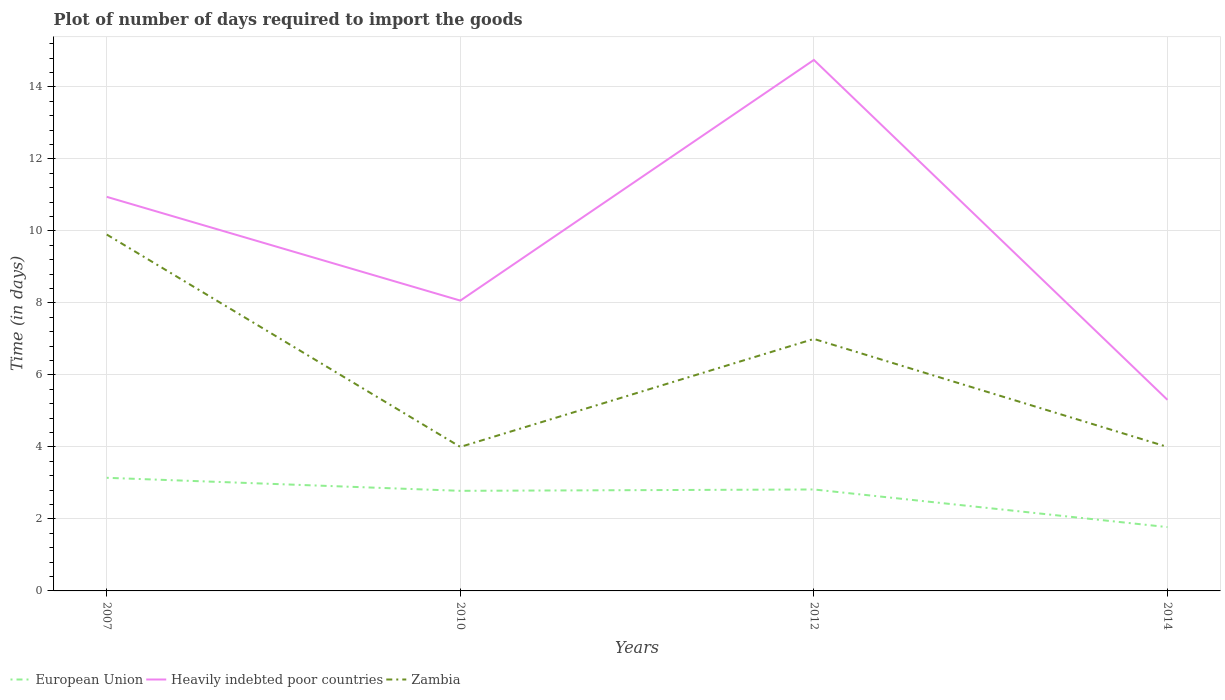Does the line corresponding to Zambia intersect with the line corresponding to European Union?
Make the answer very short. No. Is the number of lines equal to the number of legend labels?
Your response must be concise. Yes. Across all years, what is the maximum time required to import goods in European Union?
Your answer should be very brief. 1.77. In which year was the time required to import goods in Heavily indebted poor countries maximum?
Your answer should be very brief. 2014. What is the total time required to import goods in European Union in the graph?
Provide a succinct answer. 1.37. What is the difference between the highest and the second highest time required to import goods in Zambia?
Provide a short and direct response. 5.9. Is the time required to import goods in Zambia strictly greater than the time required to import goods in Heavily indebted poor countries over the years?
Ensure brevity in your answer.  Yes. How many lines are there?
Your answer should be compact. 3. Are the values on the major ticks of Y-axis written in scientific E-notation?
Ensure brevity in your answer.  No. Where does the legend appear in the graph?
Make the answer very short. Bottom left. How many legend labels are there?
Offer a very short reply. 3. What is the title of the graph?
Provide a succinct answer. Plot of number of days required to import the goods. Does "Moldova" appear as one of the legend labels in the graph?
Make the answer very short. No. What is the label or title of the X-axis?
Provide a short and direct response. Years. What is the label or title of the Y-axis?
Your answer should be compact. Time (in days). What is the Time (in days) of European Union in 2007?
Offer a very short reply. 3.14. What is the Time (in days) of Heavily indebted poor countries in 2007?
Your answer should be compact. 10.95. What is the Time (in days) in European Union in 2010?
Your response must be concise. 2.78. What is the Time (in days) of Heavily indebted poor countries in 2010?
Make the answer very short. 8.06. What is the Time (in days) of Zambia in 2010?
Your response must be concise. 4. What is the Time (in days) of European Union in 2012?
Keep it short and to the point. 2.82. What is the Time (in days) in Heavily indebted poor countries in 2012?
Offer a terse response. 14.75. What is the Time (in days) in Zambia in 2012?
Your answer should be compact. 7. What is the Time (in days) of European Union in 2014?
Offer a terse response. 1.77. What is the Time (in days) of Heavily indebted poor countries in 2014?
Your answer should be very brief. 5.31. What is the Time (in days) of Zambia in 2014?
Offer a very short reply. 4. Across all years, what is the maximum Time (in days) in European Union?
Keep it short and to the point. 3.14. Across all years, what is the maximum Time (in days) in Heavily indebted poor countries?
Keep it short and to the point. 14.75. Across all years, what is the maximum Time (in days) in Zambia?
Provide a succinct answer. 9.9. Across all years, what is the minimum Time (in days) in European Union?
Provide a short and direct response. 1.77. Across all years, what is the minimum Time (in days) of Heavily indebted poor countries?
Offer a terse response. 5.31. Across all years, what is the minimum Time (in days) in Zambia?
Make the answer very short. 4. What is the total Time (in days) in European Union in the graph?
Offer a very short reply. 10.51. What is the total Time (in days) in Heavily indebted poor countries in the graph?
Provide a succinct answer. 39.07. What is the total Time (in days) in Zambia in the graph?
Give a very brief answer. 24.9. What is the difference between the Time (in days) of European Union in 2007 and that in 2010?
Your response must be concise. 0.36. What is the difference between the Time (in days) of Heavily indebted poor countries in 2007 and that in 2010?
Your response must be concise. 2.88. What is the difference between the Time (in days) of Zambia in 2007 and that in 2010?
Keep it short and to the point. 5.9. What is the difference between the Time (in days) in European Union in 2007 and that in 2012?
Ensure brevity in your answer.  0.32. What is the difference between the Time (in days) in Heavily indebted poor countries in 2007 and that in 2012?
Your response must be concise. -3.8. What is the difference between the Time (in days) of European Union in 2007 and that in 2014?
Make the answer very short. 1.37. What is the difference between the Time (in days) of Heavily indebted poor countries in 2007 and that in 2014?
Provide a succinct answer. 5.64. What is the difference between the Time (in days) in European Union in 2010 and that in 2012?
Make the answer very short. -0.04. What is the difference between the Time (in days) of Heavily indebted poor countries in 2010 and that in 2012?
Your answer should be compact. -6.69. What is the difference between the Time (in days) in European Union in 2010 and that in 2014?
Your answer should be very brief. 1.01. What is the difference between the Time (in days) in Heavily indebted poor countries in 2010 and that in 2014?
Ensure brevity in your answer.  2.76. What is the difference between the Time (in days) in Zambia in 2010 and that in 2014?
Ensure brevity in your answer.  0. What is the difference between the Time (in days) of European Union in 2012 and that in 2014?
Make the answer very short. 1.05. What is the difference between the Time (in days) of Heavily indebted poor countries in 2012 and that in 2014?
Ensure brevity in your answer.  9.44. What is the difference between the Time (in days) of Zambia in 2012 and that in 2014?
Provide a short and direct response. 3. What is the difference between the Time (in days) of European Union in 2007 and the Time (in days) of Heavily indebted poor countries in 2010?
Your answer should be compact. -4.92. What is the difference between the Time (in days) in European Union in 2007 and the Time (in days) in Zambia in 2010?
Provide a succinct answer. -0.86. What is the difference between the Time (in days) in Heavily indebted poor countries in 2007 and the Time (in days) in Zambia in 2010?
Offer a very short reply. 6.95. What is the difference between the Time (in days) of European Union in 2007 and the Time (in days) of Heavily indebted poor countries in 2012?
Your answer should be compact. -11.61. What is the difference between the Time (in days) of European Union in 2007 and the Time (in days) of Zambia in 2012?
Make the answer very short. -3.86. What is the difference between the Time (in days) in Heavily indebted poor countries in 2007 and the Time (in days) in Zambia in 2012?
Your answer should be very brief. 3.95. What is the difference between the Time (in days) of European Union in 2007 and the Time (in days) of Heavily indebted poor countries in 2014?
Make the answer very short. -2.17. What is the difference between the Time (in days) in European Union in 2007 and the Time (in days) in Zambia in 2014?
Give a very brief answer. -0.86. What is the difference between the Time (in days) in Heavily indebted poor countries in 2007 and the Time (in days) in Zambia in 2014?
Offer a very short reply. 6.95. What is the difference between the Time (in days) of European Union in 2010 and the Time (in days) of Heavily indebted poor countries in 2012?
Make the answer very short. -11.97. What is the difference between the Time (in days) in European Union in 2010 and the Time (in days) in Zambia in 2012?
Your answer should be very brief. -4.22. What is the difference between the Time (in days) in Heavily indebted poor countries in 2010 and the Time (in days) in Zambia in 2012?
Ensure brevity in your answer.  1.06. What is the difference between the Time (in days) of European Union in 2010 and the Time (in days) of Heavily indebted poor countries in 2014?
Give a very brief answer. -2.53. What is the difference between the Time (in days) of European Union in 2010 and the Time (in days) of Zambia in 2014?
Offer a very short reply. -1.22. What is the difference between the Time (in days) in Heavily indebted poor countries in 2010 and the Time (in days) in Zambia in 2014?
Provide a short and direct response. 4.06. What is the difference between the Time (in days) in European Union in 2012 and the Time (in days) in Heavily indebted poor countries in 2014?
Your response must be concise. -2.49. What is the difference between the Time (in days) of European Union in 2012 and the Time (in days) of Zambia in 2014?
Give a very brief answer. -1.18. What is the difference between the Time (in days) in Heavily indebted poor countries in 2012 and the Time (in days) in Zambia in 2014?
Your answer should be very brief. 10.75. What is the average Time (in days) in European Union per year?
Offer a terse response. 2.63. What is the average Time (in days) of Heavily indebted poor countries per year?
Provide a short and direct response. 9.77. What is the average Time (in days) in Zambia per year?
Your response must be concise. 6.22. In the year 2007, what is the difference between the Time (in days) in European Union and Time (in days) in Heavily indebted poor countries?
Offer a terse response. -7.8. In the year 2007, what is the difference between the Time (in days) in European Union and Time (in days) in Zambia?
Your answer should be compact. -6.76. In the year 2007, what is the difference between the Time (in days) in Heavily indebted poor countries and Time (in days) in Zambia?
Your answer should be very brief. 1.05. In the year 2010, what is the difference between the Time (in days) in European Union and Time (in days) in Heavily indebted poor countries?
Offer a very short reply. -5.28. In the year 2010, what is the difference between the Time (in days) in European Union and Time (in days) in Zambia?
Give a very brief answer. -1.22. In the year 2010, what is the difference between the Time (in days) of Heavily indebted poor countries and Time (in days) of Zambia?
Provide a succinct answer. 4.06. In the year 2012, what is the difference between the Time (in days) of European Union and Time (in days) of Heavily indebted poor countries?
Make the answer very short. -11.93. In the year 2012, what is the difference between the Time (in days) of European Union and Time (in days) of Zambia?
Ensure brevity in your answer.  -4.18. In the year 2012, what is the difference between the Time (in days) of Heavily indebted poor countries and Time (in days) of Zambia?
Offer a very short reply. 7.75. In the year 2014, what is the difference between the Time (in days) of European Union and Time (in days) of Heavily indebted poor countries?
Your response must be concise. -3.54. In the year 2014, what is the difference between the Time (in days) in European Union and Time (in days) in Zambia?
Provide a succinct answer. -2.23. In the year 2014, what is the difference between the Time (in days) in Heavily indebted poor countries and Time (in days) in Zambia?
Keep it short and to the point. 1.31. What is the ratio of the Time (in days) of European Union in 2007 to that in 2010?
Provide a short and direct response. 1.13. What is the ratio of the Time (in days) in Heavily indebted poor countries in 2007 to that in 2010?
Offer a very short reply. 1.36. What is the ratio of the Time (in days) of Zambia in 2007 to that in 2010?
Offer a very short reply. 2.48. What is the ratio of the Time (in days) in European Union in 2007 to that in 2012?
Give a very brief answer. 1.11. What is the ratio of the Time (in days) in Heavily indebted poor countries in 2007 to that in 2012?
Give a very brief answer. 0.74. What is the ratio of the Time (in days) in Zambia in 2007 to that in 2012?
Offer a terse response. 1.41. What is the ratio of the Time (in days) of European Union in 2007 to that in 2014?
Provide a short and direct response. 1.77. What is the ratio of the Time (in days) of Heavily indebted poor countries in 2007 to that in 2014?
Give a very brief answer. 2.06. What is the ratio of the Time (in days) of Zambia in 2007 to that in 2014?
Offer a very short reply. 2.48. What is the ratio of the Time (in days) of European Union in 2010 to that in 2012?
Your answer should be very brief. 0.99. What is the ratio of the Time (in days) in Heavily indebted poor countries in 2010 to that in 2012?
Offer a terse response. 0.55. What is the ratio of the Time (in days) in Zambia in 2010 to that in 2012?
Make the answer very short. 0.57. What is the ratio of the Time (in days) in European Union in 2010 to that in 2014?
Your answer should be compact. 1.57. What is the ratio of the Time (in days) in Heavily indebted poor countries in 2010 to that in 2014?
Your response must be concise. 1.52. What is the ratio of the Time (in days) of European Union in 2012 to that in 2014?
Offer a very short reply. 1.59. What is the ratio of the Time (in days) of Heavily indebted poor countries in 2012 to that in 2014?
Provide a short and direct response. 2.78. What is the difference between the highest and the second highest Time (in days) of European Union?
Provide a succinct answer. 0.32. What is the difference between the highest and the second highest Time (in days) in Heavily indebted poor countries?
Provide a succinct answer. 3.8. What is the difference between the highest and the second highest Time (in days) in Zambia?
Offer a very short reply. 2.9. What is the difference between the highest and the lowest Time (in days) in European Union?
Offer a very short reply. 1.37. What is the difference between the highest and the lowest Time (in days) in Heavily indebted poor countries?
Offer a terse response. 9.44. What is the difference between the highest and the lowest Time (in days) in Zambia?
Ensure brevity in your answer.  5.9. 